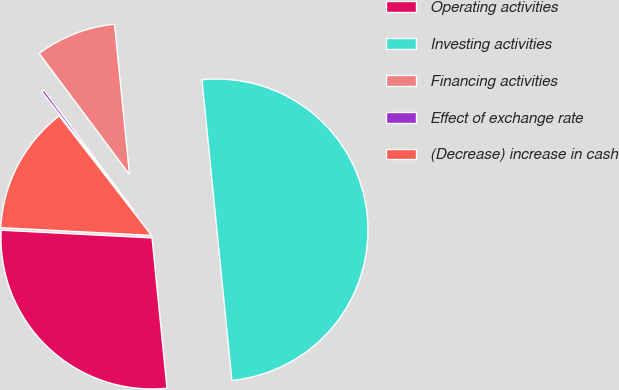<chart> <loc_0><loc_0><loc_500><loc_500><pie_chart><fcel>Operating activities<fcel>Investing activities<fcel>Financing activities<fcel>Effect of exchange rate<fcel>(Decrease) increase in cash<nl><fcel>27.39%<fcel>50.0%<fcel>8.62%<fcel>0.28%<fcel>13.71%<nl></chart> 